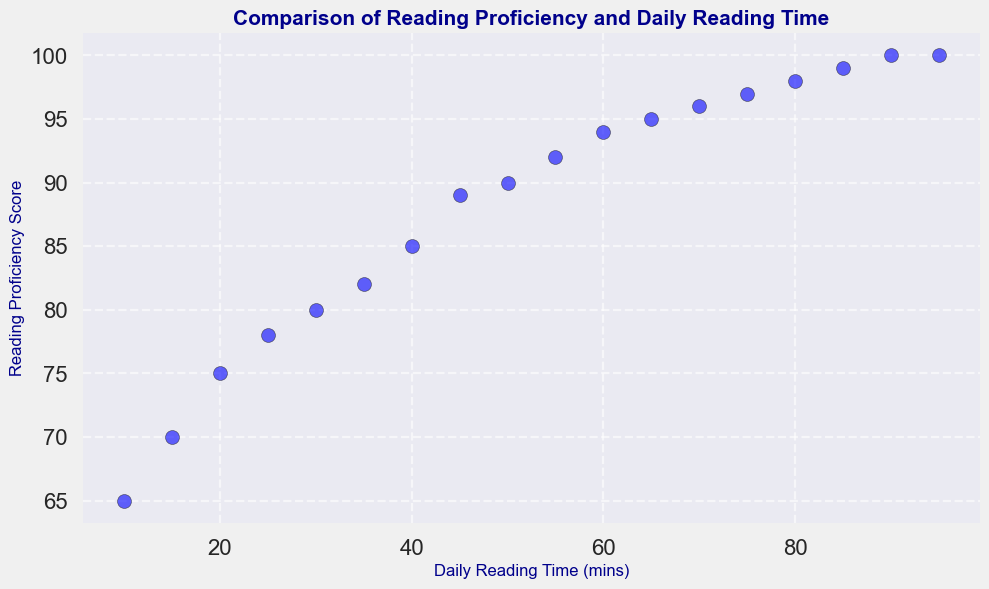What is the reading proficiency score for a student who reads for 30 minutes daily? Locate the point on the scatter plot where the x-coordinate (Daily Reading Time) is 30. The corresponding y-coordinate (Reading Proficiency Score) is 80.
Answer: 80 Compare the reading proficiency scores of students who read for 15 minutes and 50 minutes daily. Which one is higher and by how much? Locate the points for 15 and 50 minutes on the x-axis. The reading proficiency scores are 70 and 90, respectively. The difference is 90 - 70 = 20.
Answer: 50 minutes, by 20 What is the average reading proficiency score of students who read between 35 and 65 minutes daily? Identify the data points for 35, 40, 45, 50, 55, 60, and 65 minutes. The scores are 82, 85, 89, 90, 92, 94, and 95. Sum these (82 + 85 + 89 + 90 + 92 + 94 + 95) = 627 and divide by 7 (627/7).
Answer: 89.57 Does reading more minutes daily always result in a higher reading proficiency score? Observe if the scatter plot has any downward trends. Since the proficiency scores consistently increase with increasing reading time, we infer that more reading time results in higher scores.
Answer: Yes What is the change in reading proficiency score from reading for 60 minutes to reading for 80 minutes daily? Locate the points for 60 and 80 minutes on the plot. The scores are 94 and 98, respectively. The change is 98 - 94 = 4.
Answer: 4 Which daily reading time corresponds to the maximum reading proficiency score on the plot? Identify the highest y-coordinate value on the plot, which is 100. The x-coordinates corresponding to this score are 90 and 95 minutes.
Answer: 90 and 95 minutes If a student currently reads for 20 minutes and wants to increase their proficiency score by 10 points, how many additional minutes should they read daily? The score for 20 minutes is 75. To increase it by 10 points, they need an 85. The reading time for a score of 85 is 40 minutes. Thus, they need to read 40 - 20 = 20 additional minutes.
Answer: 20 minutes What is the average reading proficiency score for students who read exactly 10, 20, 30, and 40 minutes daily? Identify the scores for 10, 20, 30, and 40 minutes, which are 65, 75, 80, and 85. Sum these (65 + 75 + 80 + 85) = 305 and divide by 4 (305/4).
Answer: 76.25 Compare the reading proficiency score gain from reading 25 minutes to 45 minutes and from 55 minutes to 75 minutes. Which interval shows a higher gain? Score gain from 25 to 45 minutes is 89 - 78 = 11. Score gain from 55 to 75 minutes is 97 - 92 = 5. Thus, 25 to 45 minutes shows a higher gain.
Answer: 25 to 45 minutes by 6 What daily reading time should a student aim for to reach at least a score of 95? Identify the lowest x-coordinate where the y-coordinate is 95 or higher. The minimum daily reading times are 65 minutes, as it meets the requirement.
Answer: 65 minutes 